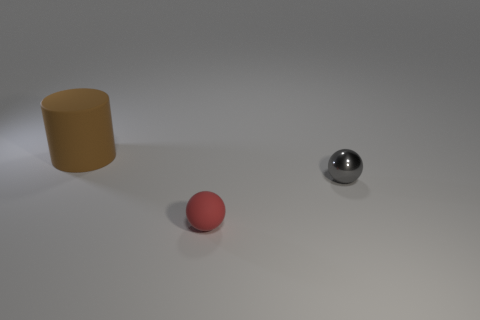Add 2 red matte things. How many objects exist? 5 Subtract all balls. How many objects are left? 1 Subtract all gray metallic spheres. Subtract all rubber objects. How many objects are left? 0 Add 1 small objects. How many small objects are left? 3 Add 3 big gray objects. How many big gray objects exist? 3 Subtract 1 gray balls. How many objects are left? 2 